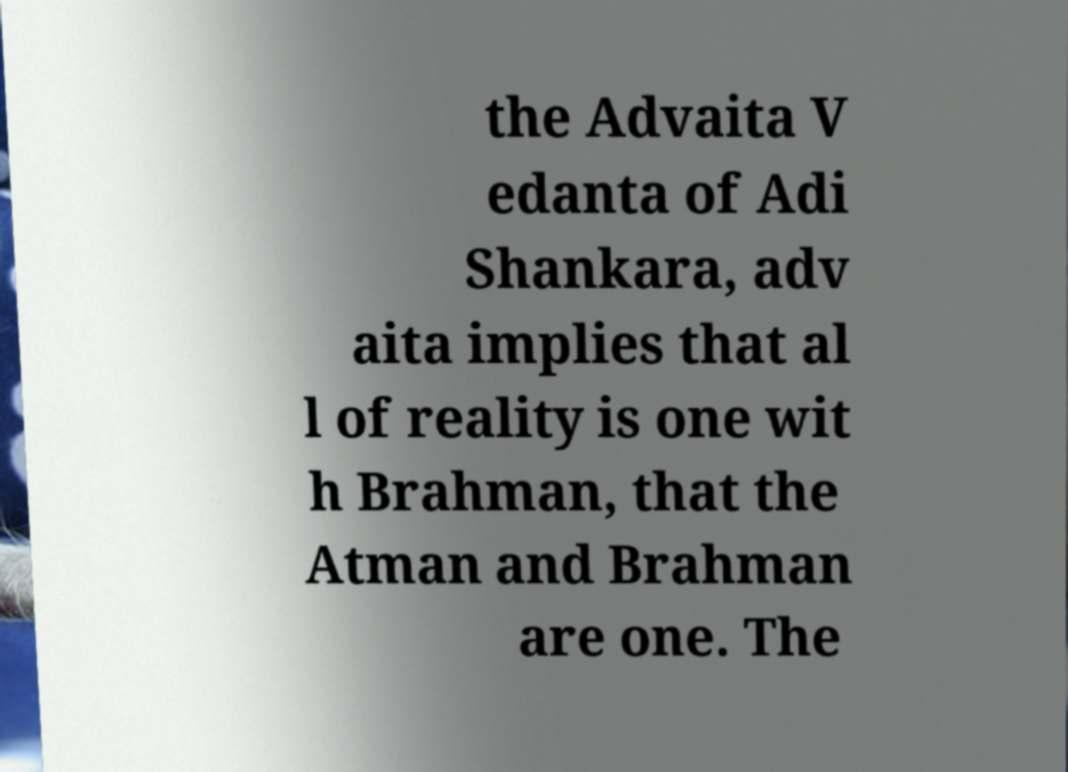For documentation purposes, I need the text within this image transcribed. Could you provide that? the Advaita V edanta of Adi Shankara, adv aita implies that al l of reality is one wit h Brahman, that the Atman and Brahman are one. The 